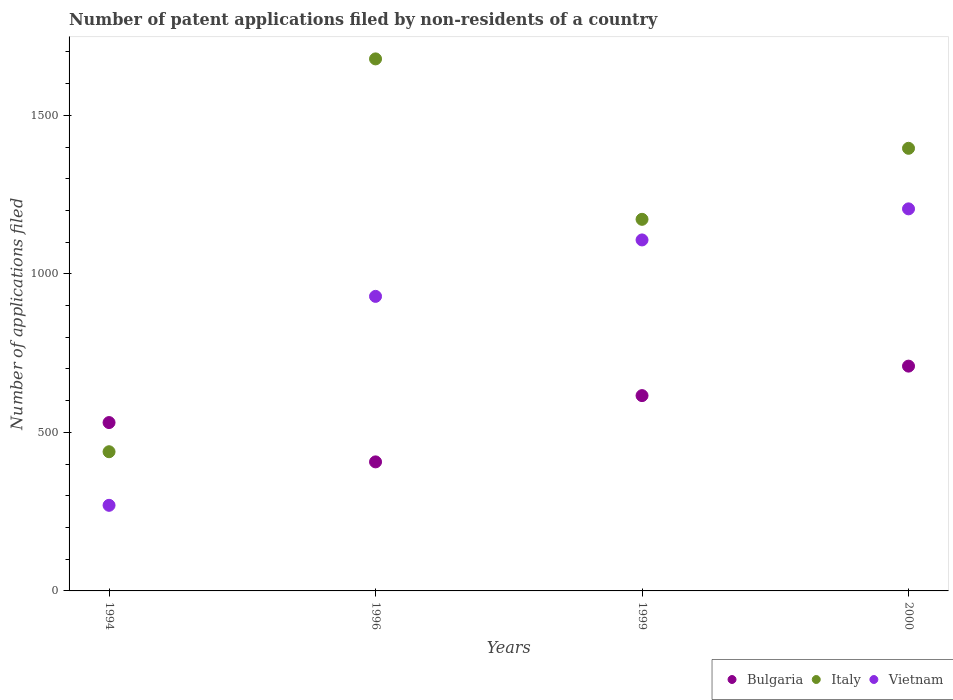What is the number of applications filed in Bulgaria in 1994?
Offer a terse response. 531. Across all years, what is the maximum number of applications filed in Bulgaria?
Ensure brevity in your answer.  709. Across all years, what is the minimum number of applications filed in Vietnam?
Provide a short and direct response. 270. In which year was the number of applications filed in Italy maximum?
Offer a terse response. 1996. What is the total number of applications filed in Vietnam in the graph?
Provide a short and direct response. 3511. What is the difference between the number of applications filed in Vietnam in 1994 and that in 1996?
Provide a short and direct response. -659. What is the difference between the number of applications filed in Vietnam in 1994 and the number of applications filed in Italy in 1996?
Your response must be concise. -1408. What is the average number of applications filed in Vietnam per year?
Your answer should be very brief. 877.75. In the year 1999, what is the difference between the number of applications filed in Vietnam and number of applications filed in Bulgaria?
Keep it short and to the point. 491. In how many years, is the number of applications filed in Vietnam greater than 1300?
Offer a terse response. 0. What is the ratio of the number of applications filed in Vietnam in 1999 to that in 2000?
Keep it short and to the point. 0.92. What is the difference between the highest and the second highest number of applications filed in Bulgaria?
Keep it short and to the point. 93. What is the difference between the highest and the lowest number of applications filed in Bulgaria?
Offer a terse response. 302. Is the sum of the number of applications filed in Italy in 1994 and 1999 greater than the maximum number of applications filed in Bulgaria across all years?
Your answer should be compact. Yes. Is it the case that in every year, the sum of the number of applications filed in Italy and number of applications filed in Vietnam  is greater than the number of applications filed in Bulgaria?
Give a very brief answer. Yes. How many dotlines are there?
Your response must be concise. 3. Where does the legend appear in the graph?
Provide a succinct answer. Bottom right. How many legend labels are there?
Provide a short and direct response. 3. What is the title of the graph?
Give a very brief answer. Number of patent applications filed by non-residents of a country. What is the label or title of the X-axis?
Make the answer very short. Years. What is the label or title of the Y-axis?
Ensure brevity in your answer.  Number of applications filed. What is the Number of applications filed of Bulgaria in 1994?
Give a very brief answer. 531. What is the Number of applications filed in Italy in 1994?
Ensure brevity in your answer.  439. What is the Number of applications filed of Vietnam in 1994?
Make the answer very short. 270. What is the Number of applications filed in Bulgaria in 1996?
Provide a short and direct response. 407. What is the Number of applications filed of Italy in 1996?
Make the answer very short. 1678. What is the Number of applications filed in Vietnam in 1996?
Your answer should be very brief. 929. What is the Number of applications filed in Bulgaria in 1999?
Provide a short and direct response. 616. What is the Number of applications filed in Italy in 1999?
Provide a succinct answer. 1172. What is the Number of applications filed in Vietnam in 1999?
Your answer should be very brief. 1107. What is the Number of applications filed of Bulgaria in 2000?
Offer a terse response. 709. What is the Number of applications filed in Italy in 2000?
Your answer should be compact. 1396. What is the Number of applications filed in Vietnam in 2000?
Offer a terse response. 1205. Across all years, what is the maximum Number of applications filed in Bulgaria?
Provide a succinct answer. 709. Across all years, what is the maximum Number of applications filed in Italy?
Your answer should be very brief. 1678. Across all years, what is the maximum Number of applications filed in Vietnam?
Keep it short and to the point. 1205. Across all years, what is the minimum Number of applications filed in Bulgaria?
Offer a very short reply. 407. Across all years, what is the minimum Number of applications filed in Italy?
Give a very brief answer. 439. Across all years, what is the minimum Number of applications filed of Vietnam?
Your answer should be very brief. 270. What is the total Number of applications filed of Bulgaria in the graph?
Ensure brevity in your answer.  2263. What is the total Number of applications filed of Italy in the graph?
Offer a terse response. 4685. What is the total Number of applications filed in Vietnam in the graph?
Offer a very short reply. 3511. What is the difference between the Number of applications filed in Bulgaria in 1994 and that in 1996?
Offer a terse response. 124. What is the difference between the Number of applications filed in Italy in 1994 and that in 1996?
Offer a terse response. -1239. What is the difference between the Number of applications filed of Vietnam in 1994 and that in 1996?
Provide a succinct answer. -659. What is the difference between the Number of applications filed of Bulgaria in 1994 and that in 1999?
Your response must be concise. -85. What is the difference between the Number of applications filed in Italy in 1994 and that in 1999?
Your answer should be compact. -733. What is the difference between the Number of applications filed in Vietnam in 1994 and that in 1999?
Make the answer very short. -837. What is the difference between the Number of applications filed in Bulgaria in 1994 and that in 2000?
Your answer should be very brief. -178. What is the difference between the Number of applications filed in Italy in 1994 and that in 2000?
Your answer should be very brief. -957. What is the difference between the Number of applications filed of Vietnam in 1994 and that in 2000?
Your answer should be very brief. -935. What is the difference between the Number of applications filed in Bulgaria in 1996 and that in 1999?
Your answer should be very brief. -209. What is the difference between the Number of applications filed of Italy in 1996 and that in 1999?
Offer a terse response. 506. What is the difference between the Number of applications filed in Vietnam in 1996 and that in 1999?
Your response must be concise. -178. What is the difference between the Number of applications filed of Bulgaria in 1996 and that in 2000?
Ensure brevity in your answer.  -302. What is the difference between the Number of applications filed of Italy in 1996 and that in 2000?
Your response must be concise. 282. What is the difference between the Number of applications filed in Vietnam in 1996 and that in 2000?
Offer a terse response. -276. What is the difference between the Number of applications filed in Bulgaria in 1999 and that in 2000?
Give a very brief answer. -93. What is the difference between the Number of applications filed in Italy in 1999 and that in 2000?
Your response must be concise. -224. What is the difference between the Number of applications filed of Vietnam in 1999 and that in 2000?
Make the answer very short. -98. What is the difference between the Number of applications filed of Bulgaria in 1994 and the Number of applications filed of Italy in 1996?
Offer a very short reply. -1147. What is the difference between the Number of applications filed of Bulgaria in 1994 and the Number of applications filed of Vietnam in 1996?
Provide a succinct answer. -398. What is the difference between the Number of applications filed in Italy in 1994 and the Number of applications filed in Vietnam in 1996?
Your response must be concise. -490. What is the difference between the Number of applications filed in Bulgaria in 1994 and the Number of applications filed in Italy in 1999?
Your response must be concise. -641. What is the difference between the Number of applications filed in Bulgaria in 1994 and the Number of applications filed in Vietnam in 1999?
Offer a terse response. -576. What is the difference between the Number of applications filed of Italy in 1994 and the Number of applications filed of Vietnam in 1999?
Your answer should be compact. -668. What is the difference between the Number of applications filed in Bulgaria in 1994 and the Number of applications filed in Italy in 2000?
Your response must be concise. -865. What is the difference between the Number of applications filed of Bulgaria in 1994 and the Number of applications filed of Vietnam in 2000?
Your response must be concise. -674. What is the difference between the Number of applications filed of Italy in 1994 and the Number of applications filed of Vietnam in 2000?
Offer a very short reply. -766. What is the difference between the Number of applications filed of Bulgaria in 1996 and the Number of applications filed of Italy in 1999?
Give a very brief answer. -765. What is the difference between the Number of applications filed of Bulgaria in 1996 and the Number of applications filed of Vietnam in 1999?
Give a very brief answer. -700. What is the difference between the Number of applications filed of Italy in 1996 and the Number of applications filed of Vietnam in 1999?
Your answer should be compact. 571. What is the difference between the Number of applications filed in Bulgaria in 1996 and the Number of applications filed in Italy in 2000?
Offer a very short reply. -989. What is the difference between the Number of applications filed in Bulgaria in 1996 and the Number of applications filed in Vietnam in 2000?
Ensure brevity in your answer.  -798. What is the difference between the Number of applications filed in Italy in 1996 and the Number of applications filed in Vietnam in 2000?
Offer a terse response. 473. What is the difference between the Number of applications filed in Bulgaria in 1999 and the Number of applications filed in Italy in 2000?
Make the answer very short. -780. What is the difference between the Number of applications filed in Bulgaria in 1999 and the Number of applications filed in Vietnam in 2000?
Your answer should be very brief. -589. What is the difference between the Number of applications filed of Italy in 1999 and the Number of applications filed of Vietnam in 2000?
Provide a short and direct response. -33. What is the average Number of applications filed in Bulgaria per year?
Make the answer very short. 565.75. What is the average Number of applications filed of Italy per year?
Provide a short and direct response. 1171.25. What is the average Number of applications filed in Vietnam per year?
Give a very brief answer. 877.75. In the year 1994, what is the difference between the Number of applications filed in Bulgaria and Number of applications filed in Italy?
Keep it short and to the point. 92. In the year 1994, what is the difference between the Number of applications filed in Bulgaria and Number of applications filed in Vietnam?
Offer a terse response. 261. In the year 1994, what is the difference between the Number of applications filed of Italy and Number of applications filed of Vietnam?
Your answer should be compact. 169. In the year 1996, what is the difference between the Number of applications filed in Bulgaria and Number of applications filed in Italy?
Your response must be concise. -1271. In the year 1996, what is the difference between the Number of applications filed in Bulgaria and Number of applications filed in Vietnam?
Your answer should be very brief. -522. In the year 1996, what is the difference between the Number of applications filed in Italy and Number of applications filed in Vietnam?
Your answer should be very brief. 749. In the year 1999, what is the difference between the Number of applications filed of Bulgaria and Number of applications filed of Italy?
Give a very brief answer. -556. In the year 1999, what is the difference between the Number of applications filed of Bulgaria and Number of applications filed of Vietnam?
Ensure brevity in your answer.  -491. In the year 1999, what is the difference between the Number of applications filed of Italy and Number of applications filed of Vietnam?
Your response must be concise. 65. In the year 2000, what is the difference between the Number of applications filed of Bulgaria and Number of applications filed of Italy?
Your answer should be very brief. -687. In the year 2000, what is the difference between the Number of applications filed in Bulgaria and Number of applications filed in Vietnam?
Give a very brief answer. -496. In the year 2000, what is the difference between the Number of applications filed in Italy and Number of applications filed in Vietnam?
Provide a succinct answer. 191. What is the ratio of the Number of applications filed in Bulgaria in 1994 to that in 1996?
Keep it short and to the point. 1.3. What is the ratio of the Number of applications filed in Italy in 1994 to that in 1996?
Provide a succinct answer. 0.26. What is the ratio of the Number of applications filed in Vietnam in 1994 to that in 1996?
Give a very brief answer. 0.29. What is the ratio of the Number of applications filed of Bulgaria in 1994 to that in 1999?
Your response must be concise. 0.86. What is the ratio of the Number of applications filed in Italy in 1994 to that in 1999?
Keep it short and to the point. 0.37. What is the ratio of the Number of applications filed of Vietnam in 1994 to that in 1999?
Make the answer very short. 0.24. What is the ratio of the Number of applications filed of Bulgaria in 1994 to that in 2000?
Make the answer very short. 0.75. What is the ratio of the Number of applications filed in Italy in 1994 to that in 2000?
Your answer should be compact. 0.31. What is the ratio of the Number of applications filed in Vietnam in 1994 to that in 2000?
Offer a terse response. 0.22. What is the ratio of the Number of applications filed in Bulgaria in 1996 to that in 1999?
Offer a very short reply. 0.66. What is the ratio of the Number of applications filed in Italy in 1996 to that in 1999?
Your answer should be compact. 1.43. What is the ratio of the Number of applications filed of Vietnam in 1996 to that in 1999?
Your answer should be compact. 0.84. What is the ratio of the Number of applications filed of Bulgaria in 1996 to that in 2000?
Your answer should be very brief. 0.57. What is the ratio of the Number of applications filed in Italy in 1996 to that in 2000?
Provide a short and direct response. 1.2. What is the ratio of the Number of applications filed of Vietnam in 1996 to that in 2000?
Provide a succinct answer. 0.77. What is the ratio of the Number of applications filed of Bulgaria in 1999 to that in 2000?
Give a very brief answer. 0.87. What is the ratio of the Number of applications filed in Italy in 1999 to that in 2000?
Provide a succinct answer. 0.84. What is the ratio of the Number of applications filed of Vietnam in 1999 to that in 2000?
Your response must be concise. 0.92. What is the difference between the highest and the second highest Number of applications filed of Bulgaria?
Your answer should be compact. 93. What is the difference between the highest and the second highest Number of applications filed of Italy?
Offer a very short reply. 282. What is the difference between the highest and the lowest Number of applications filed of Bulgaria?
Provide a succinct answer. 302. What is the difference between the highest and the lowest Number of applications filed in Italy?
Your response must be concise. 1239. What is the difference between the highest and the lowest Number of applications filed of Vietnam?
Provide a short and direct response. 935. 